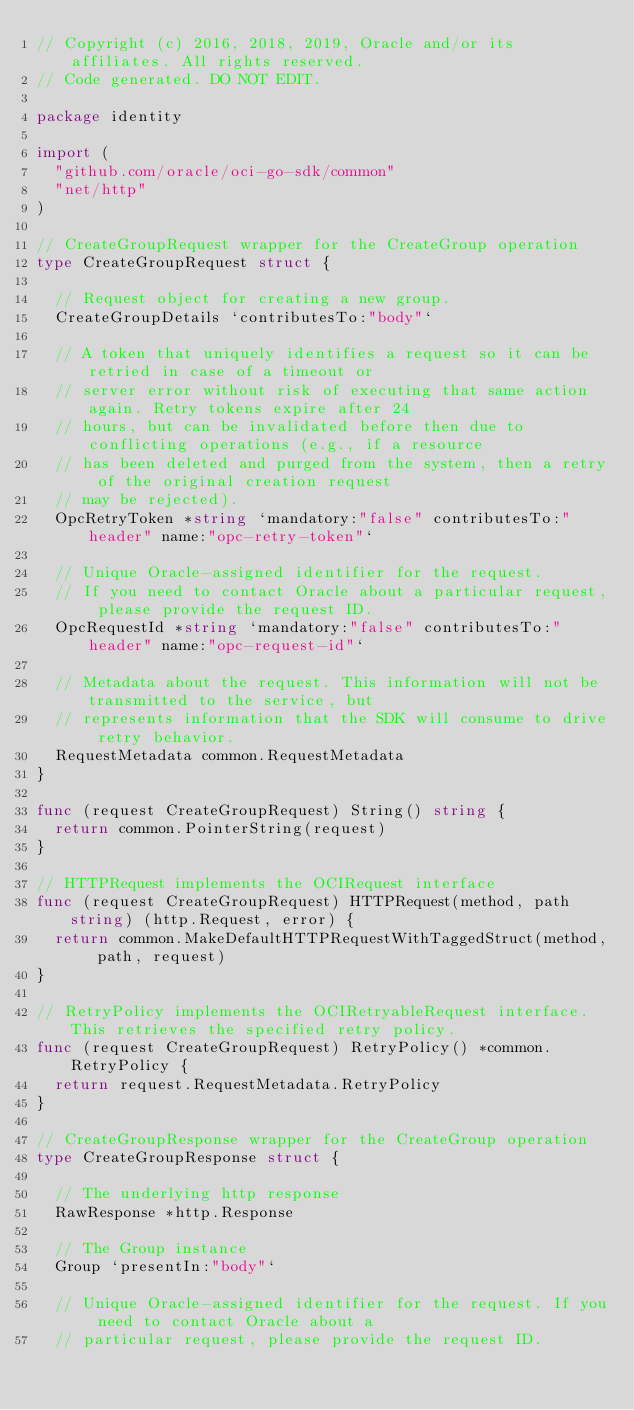<code> <loc_0><loc_0><loc_500><loc_500><_Go_>// Copyright (c) 2016, 2018, 2019, Oracle and/or its affiliates. All rights reserved.
// Code generated. DO NOT EDIT.

package identity

import (
	"github.com/oracle/oci-go-sdk/common"
	"net/http"
)

// CreateGroupRequest wrapper for the CreateGroup operation
type CreateGroupRequest struct {

	// Request object for creating a new group.
	CreateGroupDetails `contributesTo:"body"`

	// A token that uniquely identifies a request so it can be retried in case of a timeout or
	// server error without risk of executing that same action again. Retry tokens expire after 24
	// hours, but can be invalidated before then due to conflicting operations (e.g., if a resource
	// has been deleted and purged from the system, then a retry of the original creation request
	// may be rejected).
	OpcRetryToken *string `mandatory:"false" contributesTo:"header" name:"opc-retry-token"`

	// Unique Oracle-assigned identifier for the request.
	// If you need to contact Oracle about a particular request, please provide the request ID.
	OpcRequestId *string `mandatory:"false" contributesTo:"header" name:"opc-request-id"`

	// Metadata about the request. This information will not be transmitted to the service, but
	// represents information that the SDK will consume to drive retry behavior.
	RequestMetadata common.RequestMetadata
}

func (request CreateGroupRequest) String() string {
	return common.PointerString(request)
}

// HTTPRequest implements the OCIRequest interface
func (request CreateGroupRequest) HTTPRequest(method, path string) (http.Request, error) {
	return common.MakeDefaultHTTPRequestWithTaggedStruct(method, path, request)
}

// RetryPolicy implements the OCIRetryableRequest interface. This retrieves the specified retry policy.
func (request CreateGroupRequest) RetryPolicy() *common.RetryPolicy {
	return request.RequestMetadata.RetryPolicy
}

// CreateGroupResponse wrapper for the CreateGroup operation
type CreateGroupResponse struct {

	// The underlying http response
	RawResponse *http.Response

	// The Group instance
	Group `presentIn:"body"`

	// Unique Oracle-assigned identifier for the request. If you need to contact Oracle about a
	// particular request, please provide the request ID.</code> 